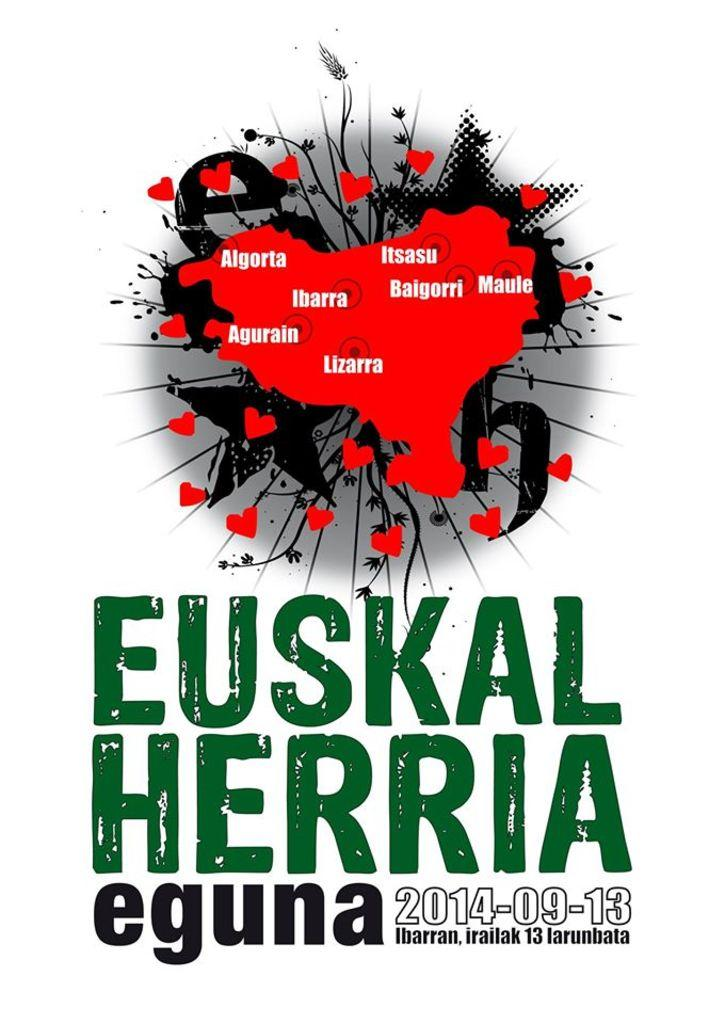<image>
Create a compact narrative representing the image presented. A poster for Euskal Herria features different shapes. 